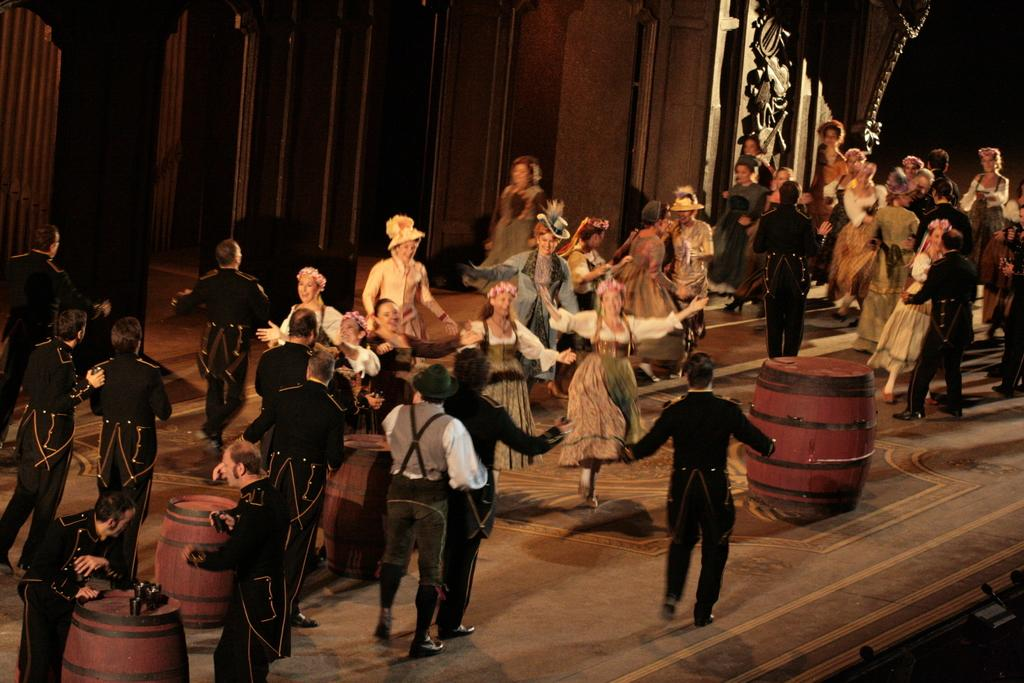What is the main subject of the image? The main subject of the image is a group of people. How are the people dressed in the image? The people are wearing different color dresses in the image. What objects are in front of some of the people? There are drums in front of some people in the image. What can be seen in the background of the image? There is a wall in the background of the image. How many birds are perched on the drums in the image? There are no birds present in the image; it only features a group of people and drums. What type of banana is being used as a drumstick in the image? There is no banana being used as a drumstick in the image; the drums are being played with traditional drumsticks or hands. 